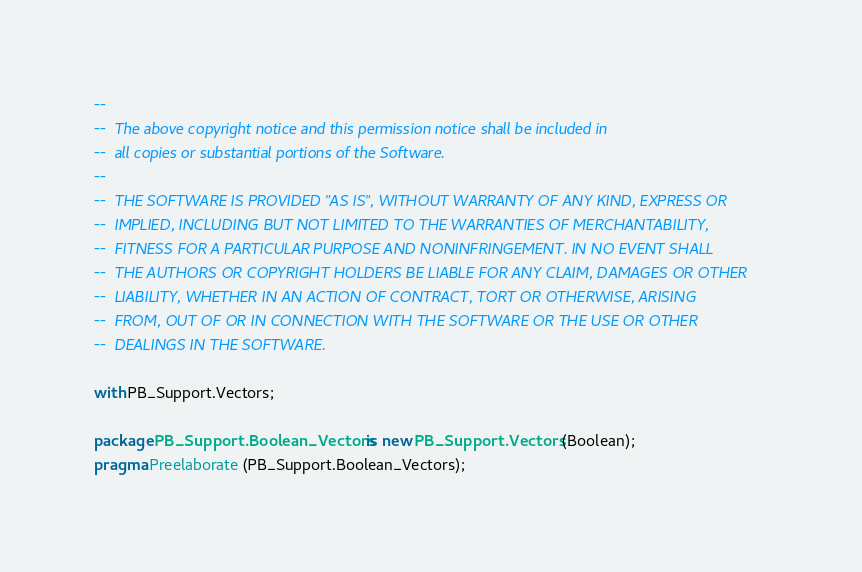Convert code to text. <code><loc_0><loc_0><loc_500><loc_500><_Ada_>--
--  The above copyright notice and this permission notice shall be included in
--  all copies or substantial portions of the Software.
--
--  THE SOFTWARE IS PROVIDED "AS IS", WITHOUT WARRANTY OF ANY KIND, EXPRESS OR
--  IMPLIED, INCLUDING BUT NOT LIMITED TO THE WARRANTIES OF MERCHANTABILITY,
--  FITNESS FOR A PARTICULAR PURPOSE AND NONINFRINGEMENT. IN NO EVENT SHALL
--  THE AUTHORS OR COPYRIGHT HOLDERS BE LIABLE FOR ANY CLAIM, DAMAGES OR OTHER
--  LIABILITY, WHETHER IN AN ACTION OF CONTRACT, TORT OR OTHERWISE, ARISING
--  FROM, OUT OF OR IN CONNECTION WITH THE SOFTWARE OR THE USE OR OTHER
--  DEALINGS IN THE SOFTWARE.

with PB_Support.Vectors;

package PB_Support.Boolean_Vectors is new PB_Support.Vectors (Boolean);
pragma Preelaborate (PB_Support.Boolean_Vectors);
</code> 